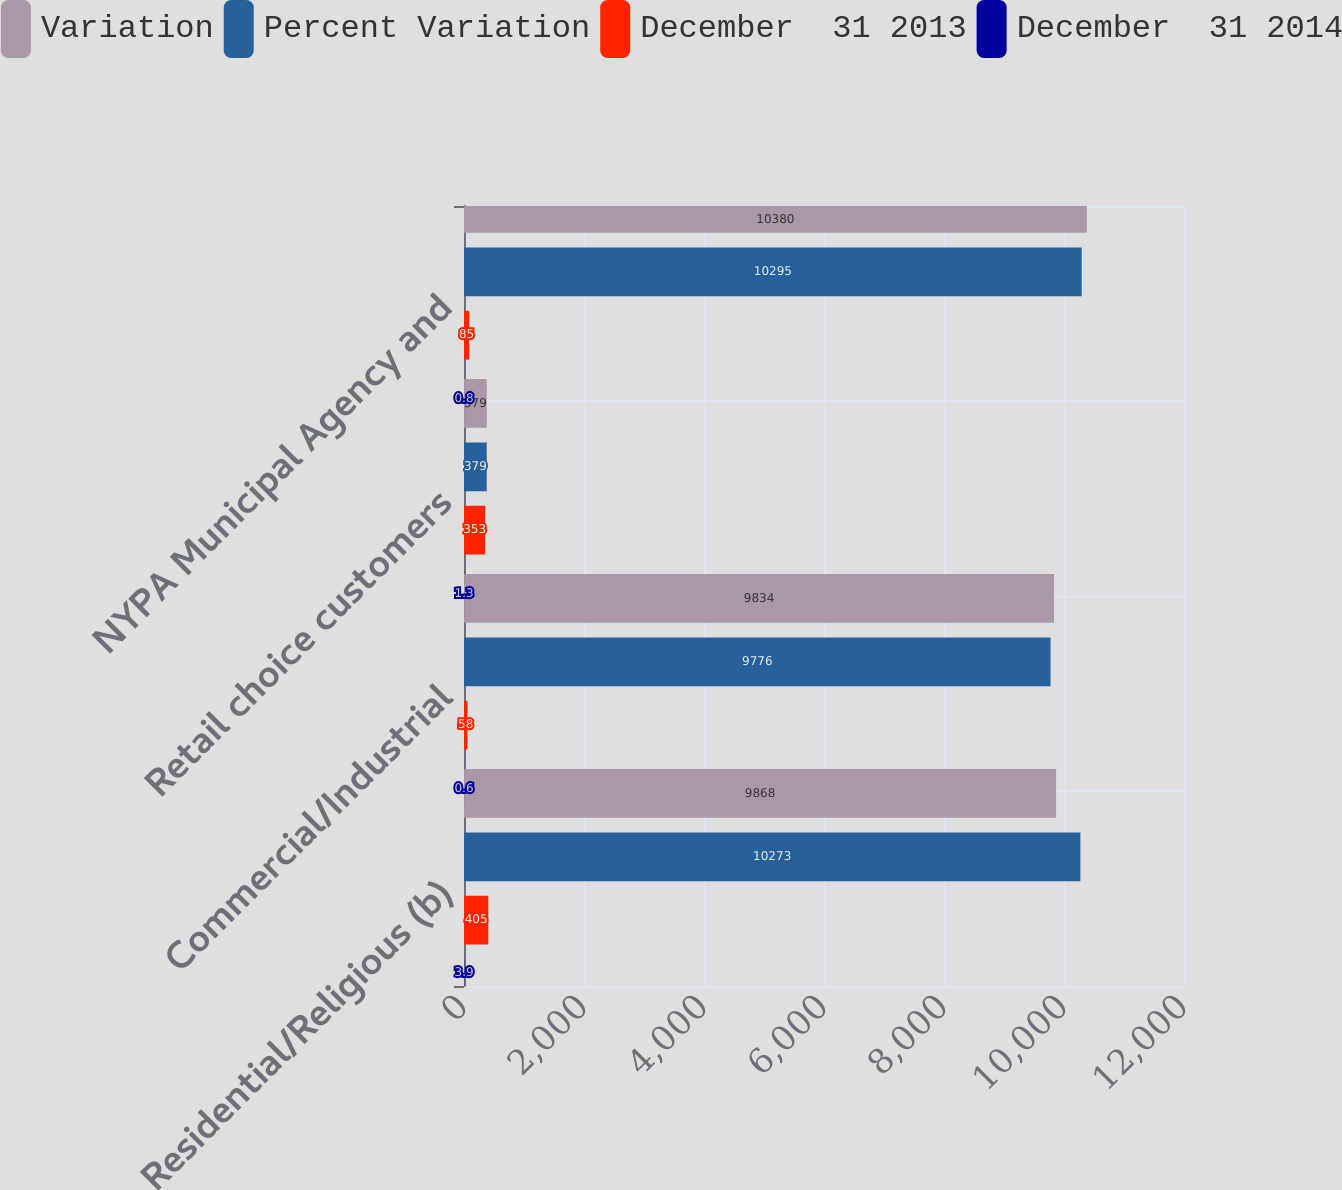<chart> <loc_0><loc_0><loc_500><loc_500><stacked_bar_chart><ecel><fcel>Residential/Religious (b)<fcel>Commercial/Industrial<fcel>Retail choice customers<fcel>NYPA Municipal Agency and<nl><fcel>Variation<fcel>9868<fcel>9834<fcel>379<fcel>10380<nl><fcel>Percent Variation<fcel>10273<fcel>9776<fcel>379<fcel>10295<nl><fcel>December  31 2013<fcel>405<fcel>58<fcel>353<fcel>85<nl><fcel>December  31 2014<fcel>3.9<fcel>0.6<fcel>1.3<fcel>0.8<nl></chart> 